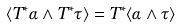<formula> <loc_0><loc_0><loc_500><loc_500>\langle T ^ { * } \alpha \wedge T ^ { * } \tau \rangle = T ^ { * } \langle \alpha \wedge \tau \rangle</formula> 